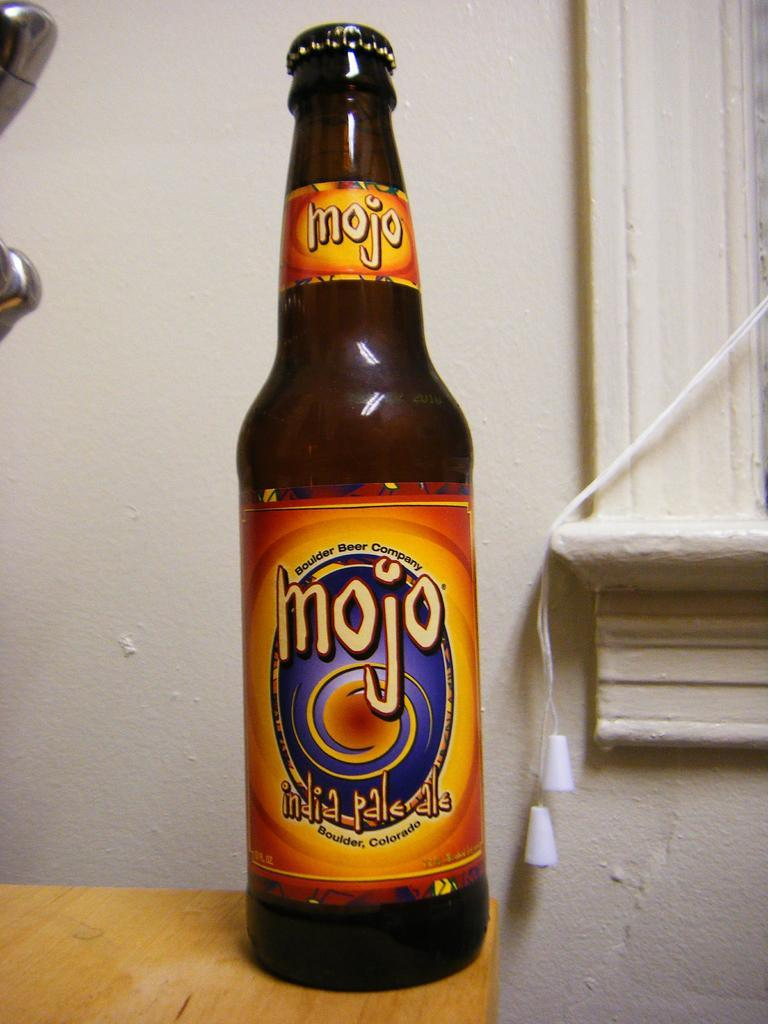<image>
Describe the image concisely. a bottle of Mojo India Pale Ale on a wooden table 